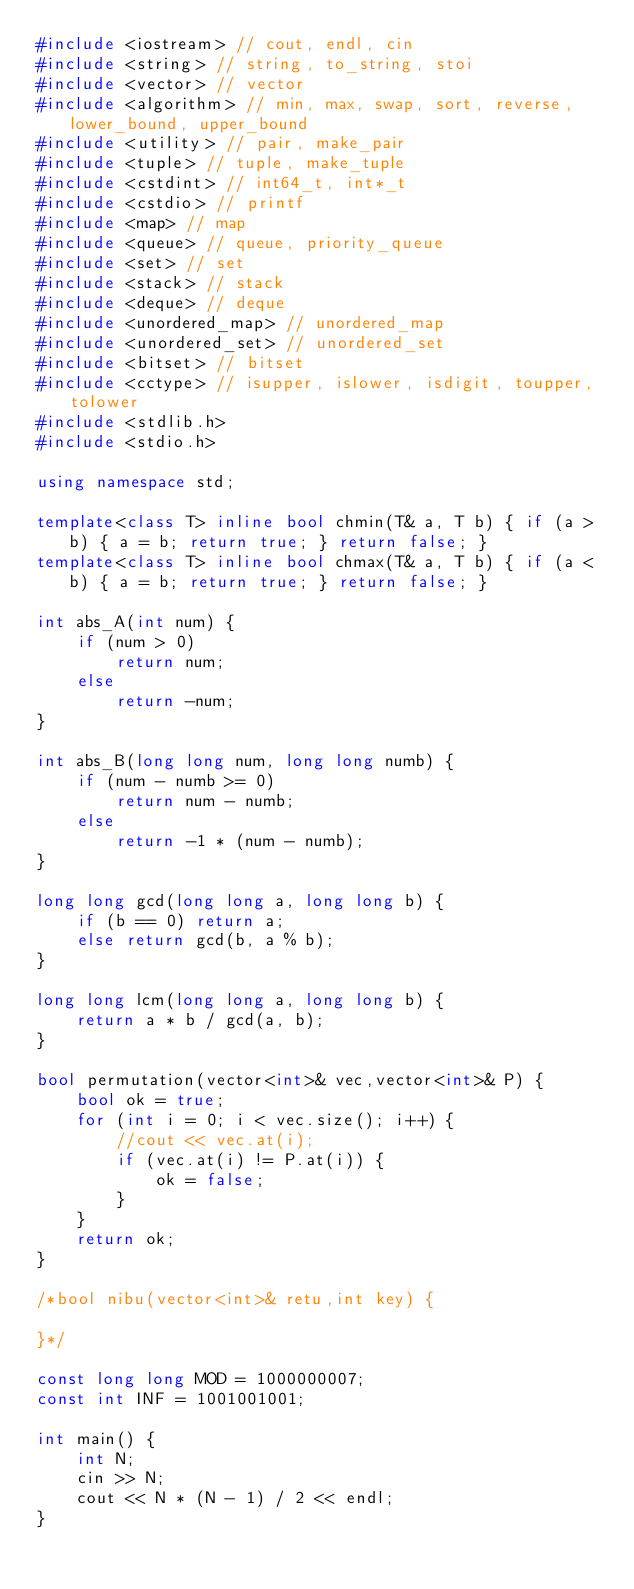<code> <loc_0><loc_0><loc_500><loc_500><_C++_>#include <iostream> // cout, endl, cin
#include <string> // string, to_string, stoi
#include <vector> // vector
#include <algorithm> // min, max, swap, sort, reverse, lower_bound, upper_bound
#include <utility> // pair, make_pair
#include <tuple> // tuple, make_tuple
#include <cstdint> // int64_t, int*_t
#include <cstdio> // printf
#include <map> // map
#include <queue> // queue, priority_queue
#include <set> // set
#include <stack> // stack
#include <deque> // deque
#include <unordered_map> // unordered_map
#include <unordered_set> // unordered_set
#include <bitset> // bitset
#include <cctype> // isupper, islower, isdigit, toupper, tolower
#include <stdlib.h>
#include <stdio.h>

using namespace std;

template<class T> inline bool chmin(T& a, T b) { if (a > b) { a = b; return true; } return false; }
template<class T> inline bool chmax(T& a, T b) { if (a < b) { a = b; return true; } return false; }

int abs_A(int num) {
    if (num > 0)
        return num;
    else
        return -num;
}

int abs_B(long long num, long long numb) {
    if (num - numb >= 0)
        return num - numb;
    else
        return -1 * (num - numb);
}

long long gcd(long long a, long long b) {
    if (b == 0) return a;
    else return gcd(b, a % b);
}

long long lcm(long long a, long long b) {
    return a * b / gcd(a, b);
}

bool permutation(vector<int>& vec,vector<int>& P) {
    bool ok = true;
    for (int i = 0; i < vec.size(); i++) {
        //cout << vec.at(i);
        if (vec.at(i) != P.at(i)) {
            ok = false;
        }
    }
    return ok;
}

/*bool nibu(vector<int>& retu,int key) {
    
}*/

const long long MOD = 1000000007;
const int INF = 1001001001;

int main() {
    int N;
    cin >> N;
    cout << N * (N - 1) / 2 << endl;
}

</code> 